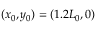Convert formula to latex. <formula><loc_0><loc_0><loc_500><loc_500>( x _ { 0 } , y _ { 0 } ) = ( 1 . 2 L _ { 0 } , 0 )</formula> 